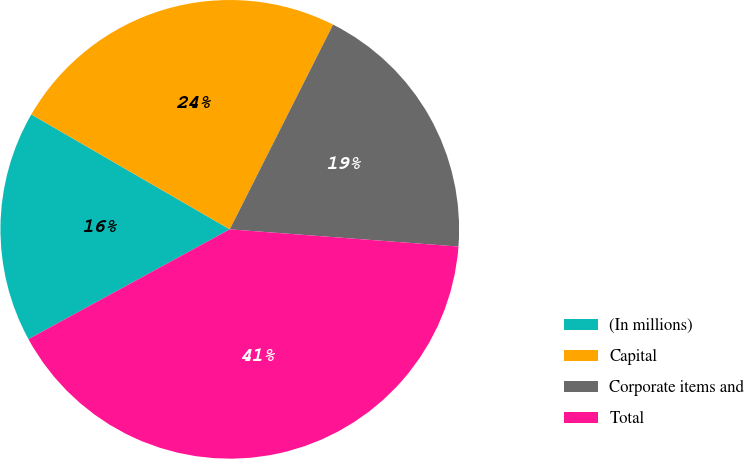Convert chart to OTSL. <chart><loc_0><loc_0><loc_500><loc_500><pie_chart><fcel>(In millions)<fcel>Capital<fcel>Corporate items and<fcel>Total<nl><fcel>16.3%<fcel>24.09%<fcel>18.76%<fcel>40.86%<nl></chart> 